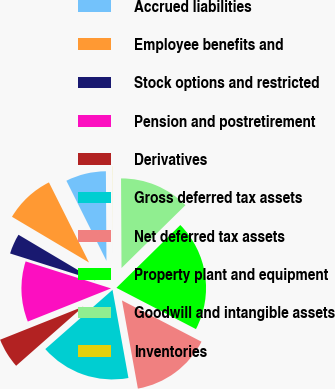<chart> <loc_0><loc_0><loc_500><loc_500><pie_chart><fcel>Accrued liabilities<fcel>Employee benefits and<fcel>Stock options and restricted<fcel>Pension and postretirement<fcel>Derivatives<fcel>Gross deferred tax assets<fcel>Net deferred tax assets<fcel>Property plant and equipment<fcel>Goodwill and intangible assets<fcel>Inventories<nl><fcel>7.28%<fcel>9.09%<fcel>3.65%<fcel>10.91%<fcel>5.46%<fcel>16.35%<fcel>14.54%<fcel>19.98%<fcel>12.72%<fcel>0.02%<nl></chart> 